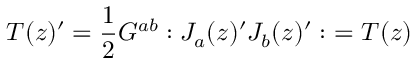<formula> <loc_0><loc_0><loc_500><loc_500>T ( z ) ^ { \prime } = \frac { 1 } { 2 } G ^ { a b } \colon J _ { a } ( z ) ^ { \prime } J _ { b } ( z ) ^ { \prime } \colon \ = T ( z )</formula> 